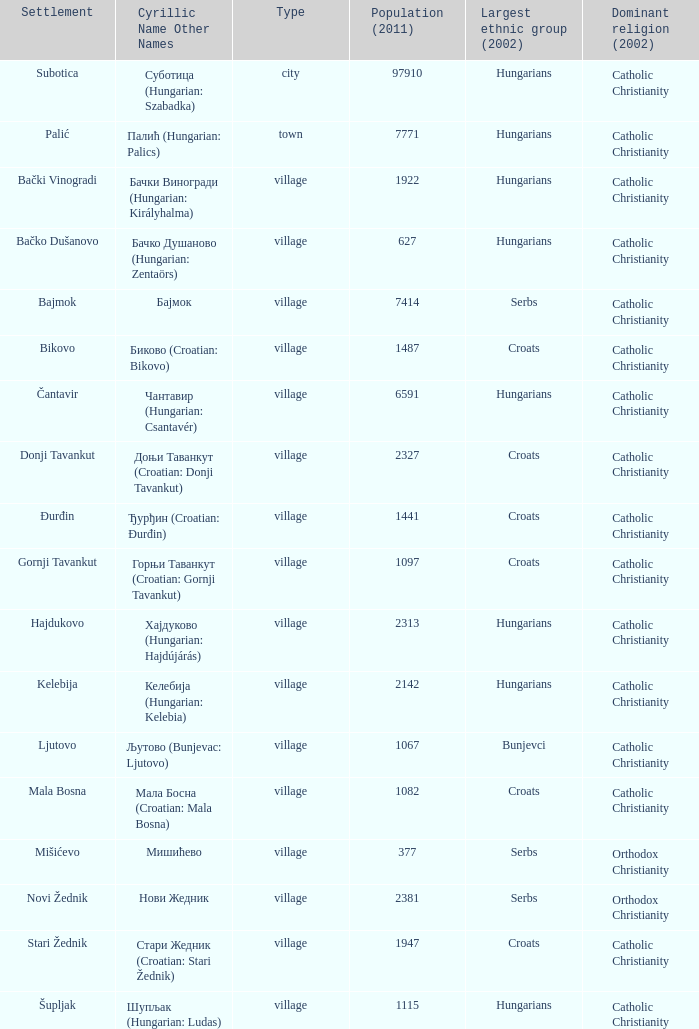What type of settlement has a population of 1441? Village. 